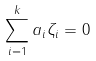<formula> <loc_0><loc_0><loc_500><loc_500>\sum _ { i = 1 } ^ { k } a _ { i } \zeta _ { i } = 0</formula> 